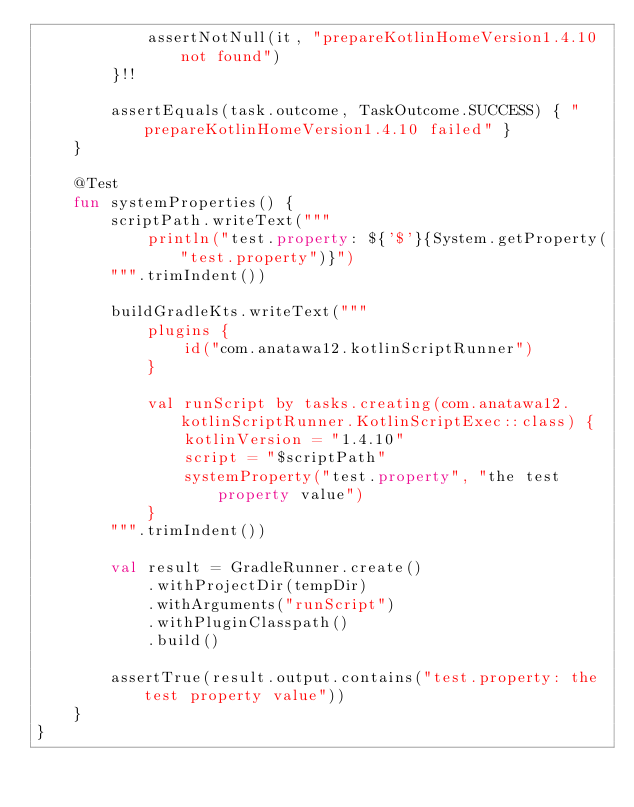Convert code to text. <code><loc_0><loc_0><loc_500><loc_500><_Kotlin_>            assertNotNull(it, "prepareKotlinHomeVersion1.4.10 not found")
        }!!

        assertEquals(task.outcome, TaskOutcome.SUCCESS) { "prepareKotlinHomeVersion1.4.10 failed" }
    }

    @Test
    fun systemProperties() {
        scriptPath.writeText("""
            println("test.property: ${'$'}{System.getProperty("test.property")}")
        """.trimIndent())

        buildGradleKts.writeText("""
            plugins {
                id("com.anatawa12.kotlinScriptRunner")
            }

            val runScript by tasks.creating(com.anatawa12.kotlinScriptRunner.KotlinScriptExec::class) {
                kotlinVersion = "1.4.10"
                script = "$scriptPath"
                systemProperty("test.property", "the test property value")
            }
        """.trimIndent())

        val result = GradleRunner.create()
            .withProjectDir(tempDir)
            .withArguments("runScript")
            .withPluginClasspath()
            .build()

        assertTrue(result.output.contains("test.property: the test property value"))
    }
}
</code> 